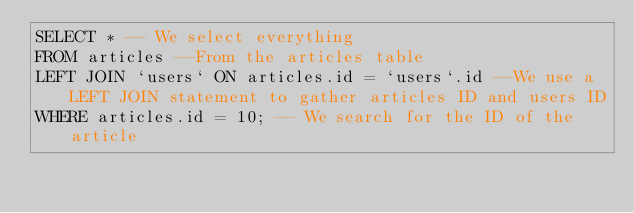<code> <loc_0><loc_0><loc_500><loc_500><_SQL_>SELECT * -- We select everything
FROM articles --From the articles table
LEFT JOIN `users` ON articles.id = `users`.id --We use a LEFT JOIN statement to gather articles ID and users ID  
WHERE articles.id = 10; -- We search for the ID of the article</code> 